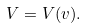Convert formula to latex. <formula><loc_0><loc_0><loc_500><loc_500>V = V ( v ) .</formula> 